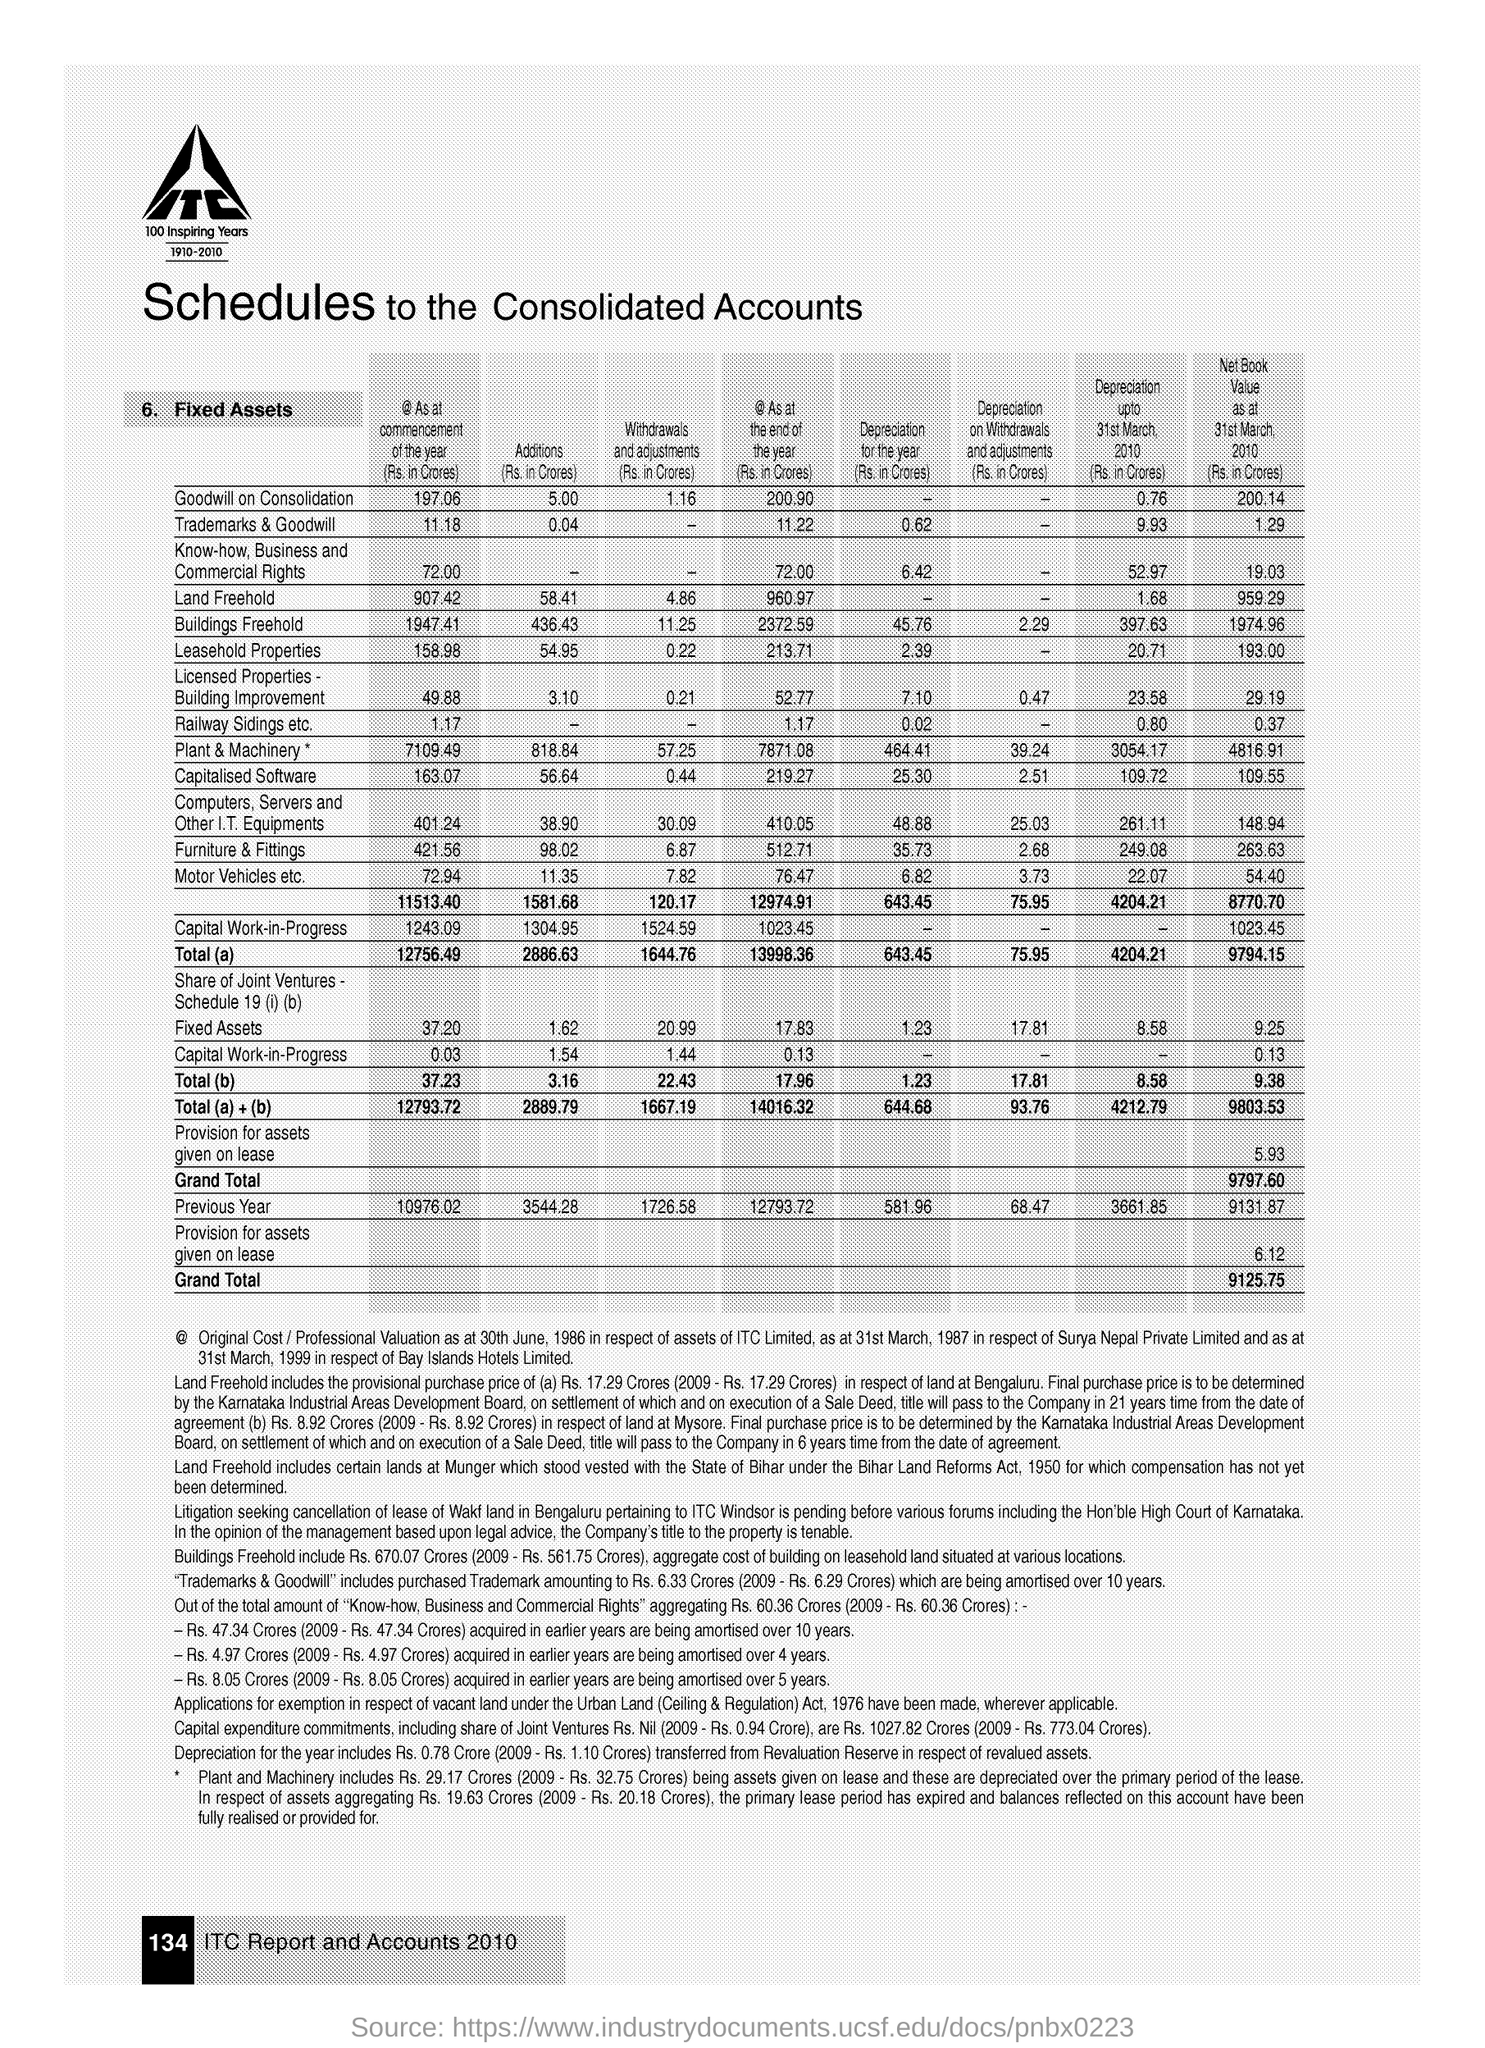List a handful of essential elements in this visual. The grand total of net book value as at March 31, 2010 was 9125.75 crores. The document title is 'Schedules to the Consolidated Accounts.' 